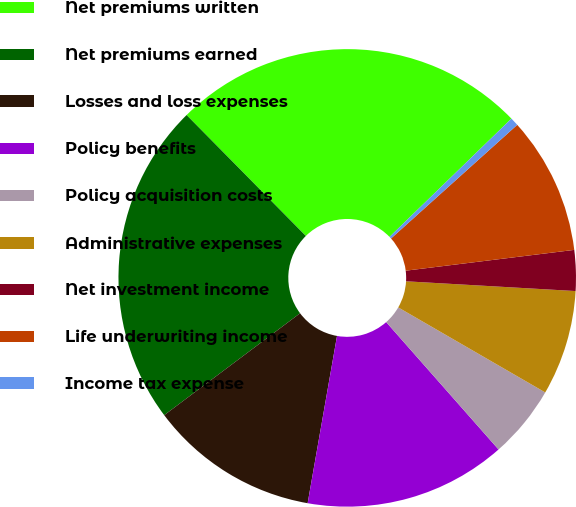<chart> <loc_0><loc_0><loc_500><loc_500><pie_chart><fcel>Net premiums written<fcel>Net premiums earned<fcel>Losses and loss expenses<fcel>Policy benefits<fcel>Policy acquisition costs<fcel>Administrative expenses<fcel>Net investment income<fcel>Life underwriting income<fcel>Income tax expense<nl><fcel>25.13%<fcel>22.85%<fcel>11.99%<fcel>14.27%<fcel>5.15%<fcel>7.43%<fcel>2.87%<fcel>9.71%<fcel>0.59%<nl></chart> 